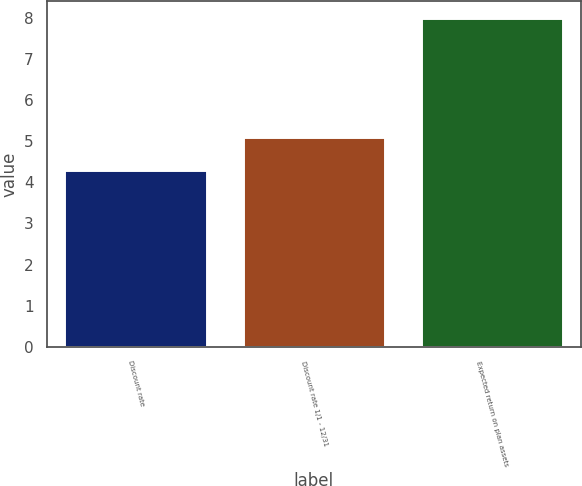Convert chart. <chart><loc_0><loc_0><loc_500><loc_500><bar_chart><fcel>Discount rate<fcel>Discount rate 1/1 - 12/31<fcel>Expected return on plan assets<nl><fcel>4.3<fcel>5.1<fcel>8<nl></chart> 